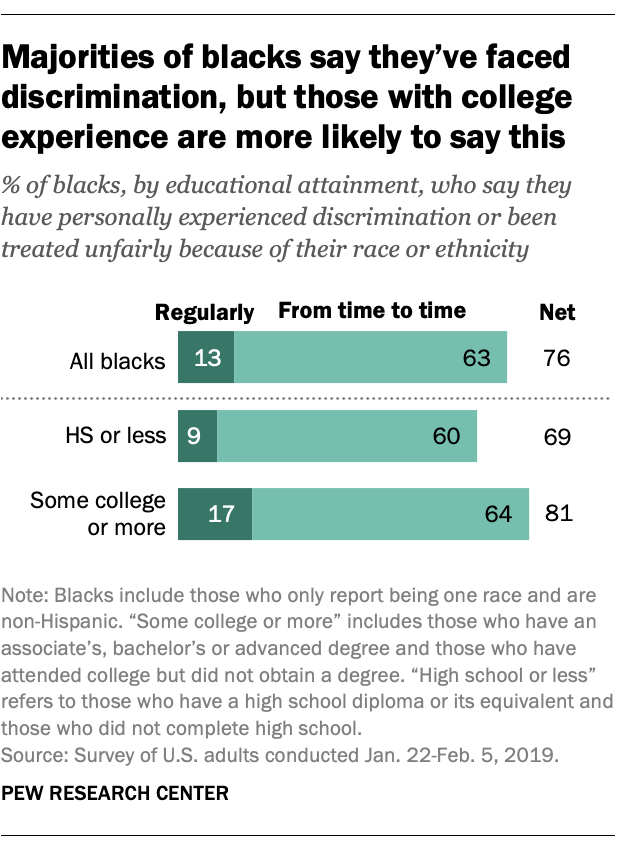Highlight a few significant elements in this photo. The net values of students who fall into the 'HS or less' category and 'Some college or more' category are 150. The net value of All Blacks who faced discrimination is 76. 